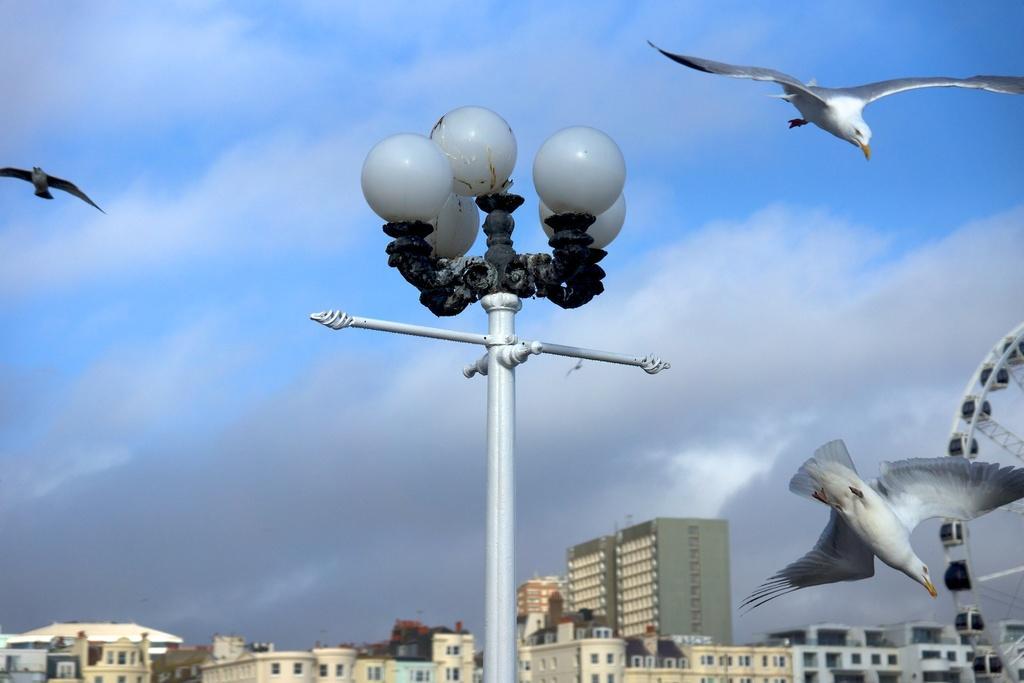Can you describe this image briefly? In this image, we can see a street pole. There are some buildings at the bottom of the image. There is a Ferris wheel in the bottom right of the image. There are birds in the sky. 